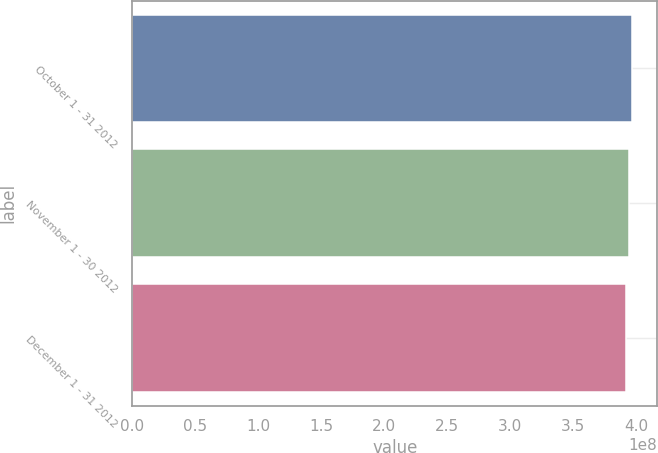Convert chart. <chart><loc_0><loc_0><loc_500><loc_500><bar_chart><fcel>October 1 - 31 2012<fcel>November 1 - 30 2012<fcel>December 1 - 31 2012<nl><fcel>3.97e+08<fcel>3.94e+08<fcel>3.92e+08<nl></chart> 